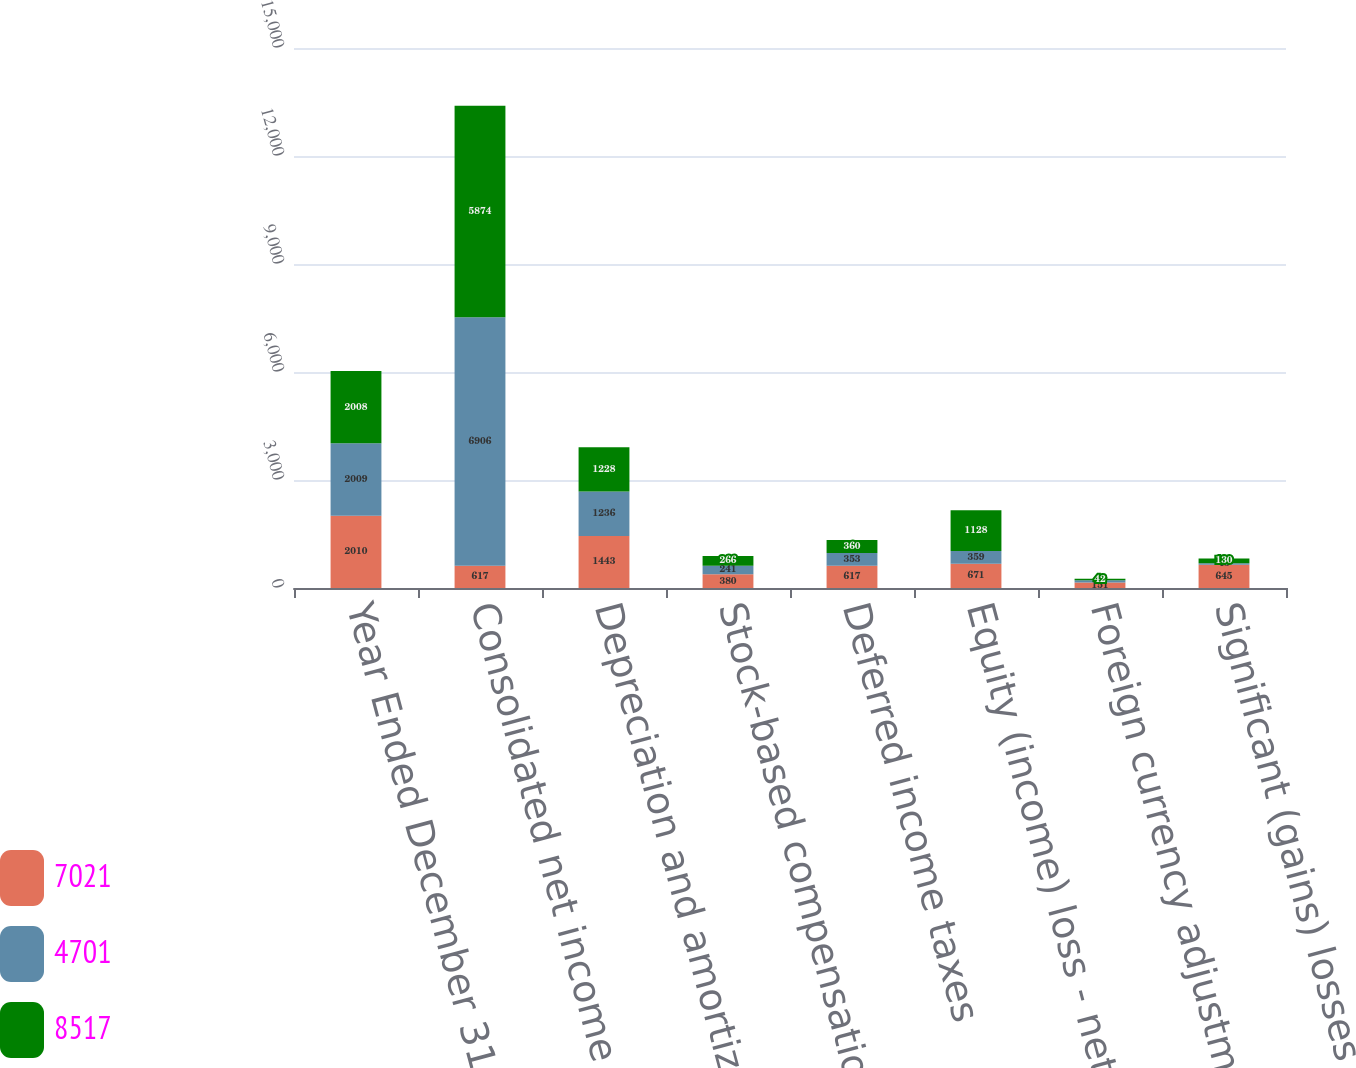Convert chart to OTSL. <chart><loc_0><loc_0><loc_500><loc_500><stacked_bar_chart><ecel><fcel>Year Ended December 31<fcel>Consolidated net income<fcel>Depreciation and amortization<fcel>Stock-based compensation<fcel>Deferred income taxes<fcel>Equity (income) loss - net of<fcel>Foreign currency adjustments<fcel>Significant (gains) losses on<nl><fcel>7021<fcel>2010<fcel>617<fcel>1443<fcel>380<fcel>617<fcel>671<fcel>151<fcel>645<nl><fcel>4701<fcel>2009<fcel>6906<fcel>1236<fcel>241<fcel>353<fcel>359<fcel>61<fcel>43<nl><fcel>8517<fcel>2008<fcel>5874<fcel>1228<fcel>266<fcel>360<fcel>1128<fcel>42<fcel>130<nl></chart> 